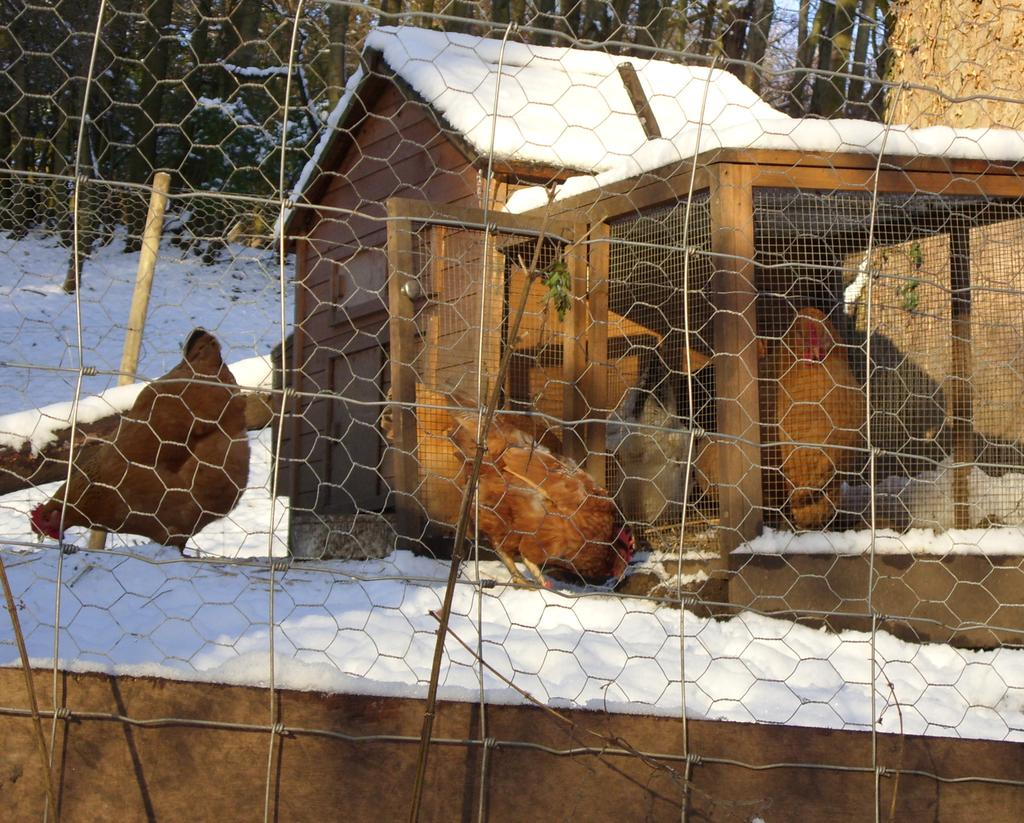What is the main structure in the center of the image? There is a shed in the center of the image. What can be seen in the foreground of the image? There is a mesh in the foreground. What type of animal is on the left side of the image? There is a hen on the left side of the image. What type of vegetation is visible in the background? There are trees in the background. What weather condition can be inferred from the image? There is snow visible in the background, suggesting a cold or wintery environment. How many cherries are hanging from the trees in the background? There are no cherries visible in the image; only trees and snow are present in the background. What is the tendency of the dust in the image? There is no dust present in the image, so it is not possible to determine its tendency. 